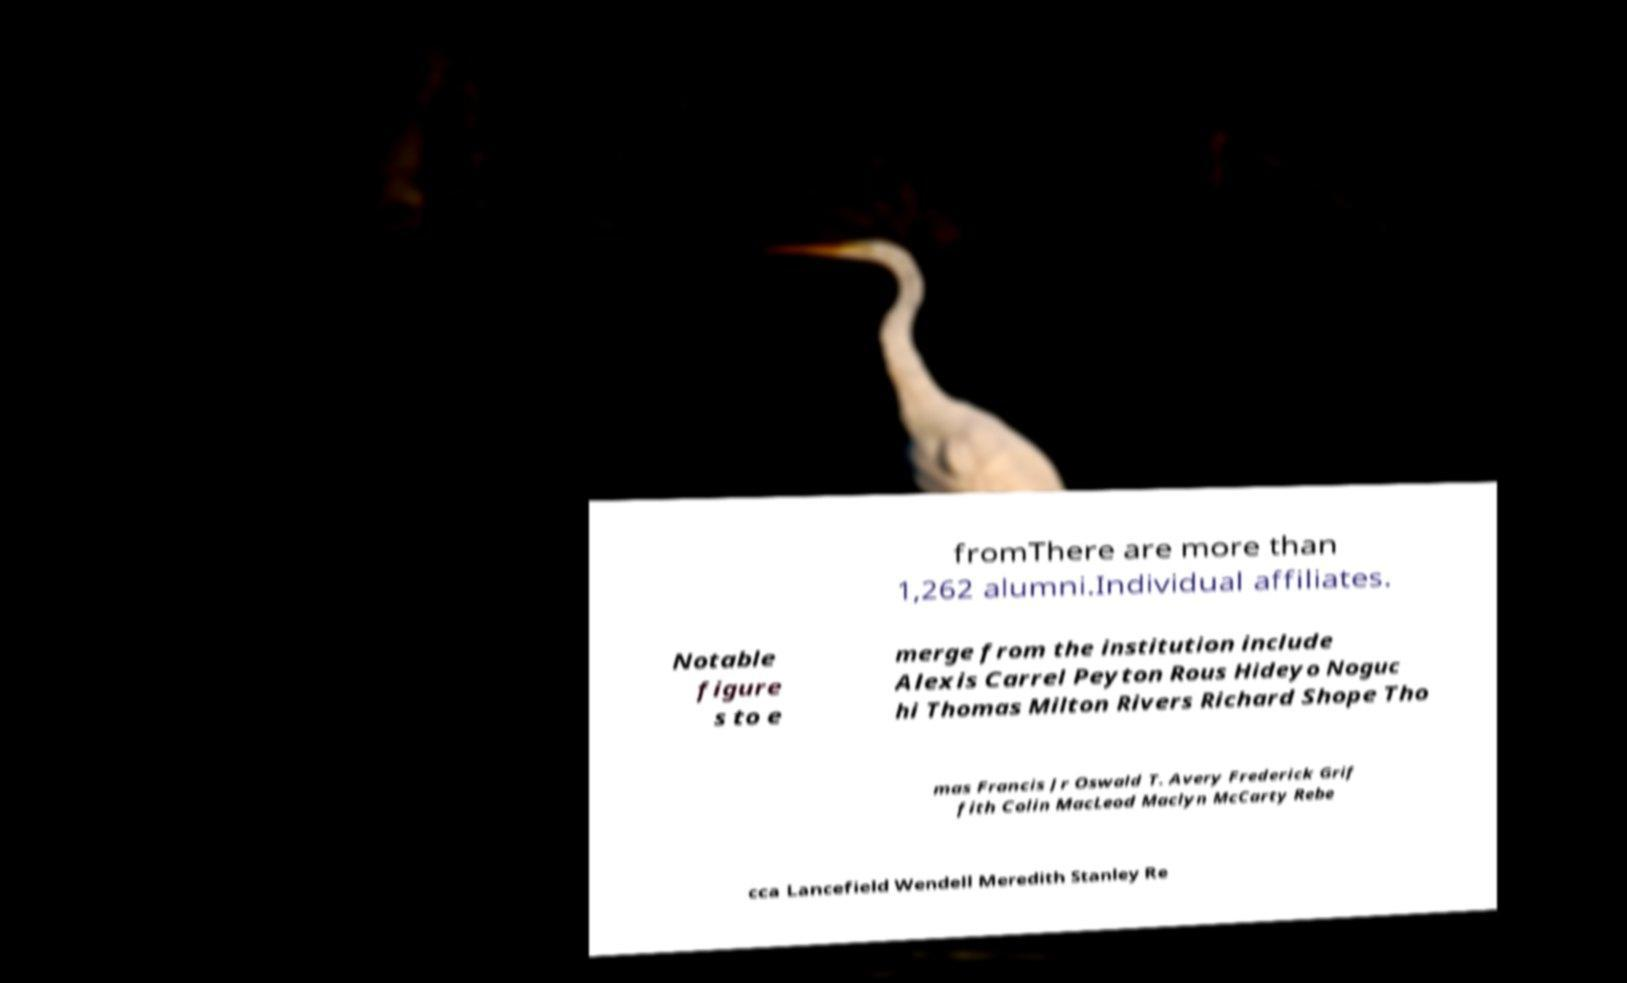Could you assist in decoding the text presented in this image and type it out clearly? fromThere are more than 1,262 alumni.Individual affiliates. Notable figure s to e merge from the institution include Alexis Carrel Peyton Rous Hideyo Noguc hi Thomas Milton Rivers Richard Shope Tho mas Francis Jr Oswald T. Avery Frederick Grif fith Colin MacLeod Maclyn McCarty Rebe cca Lancefield Wendell Meredith Stanley Re 